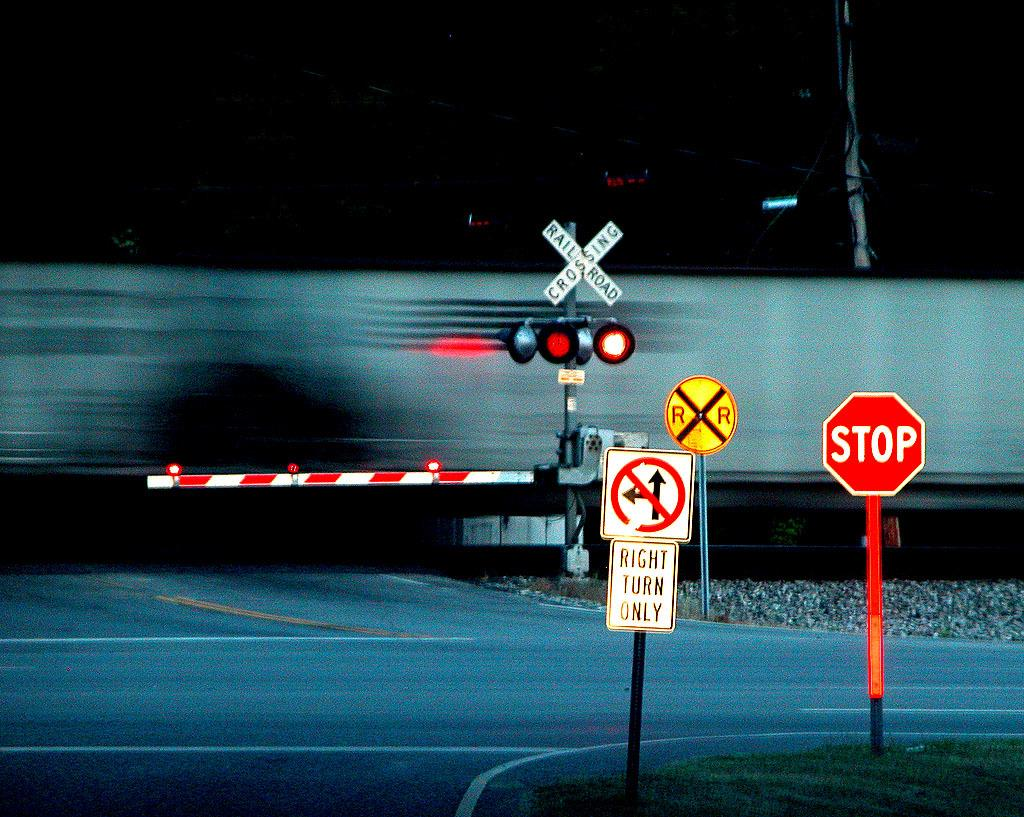<image>
Relay a brief, clear account of the picture shown. a sign with the word stop on it 